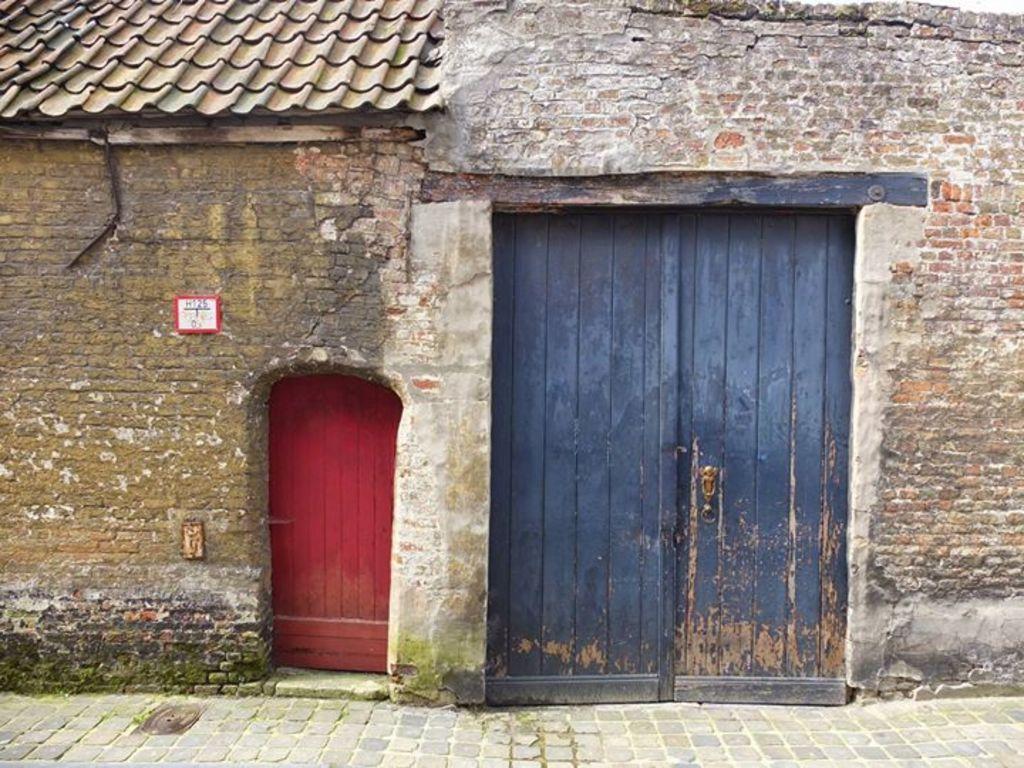Can you describe this image briefly? In the image we can see there is a building and there are two doors on the building. There is roof on the building. 